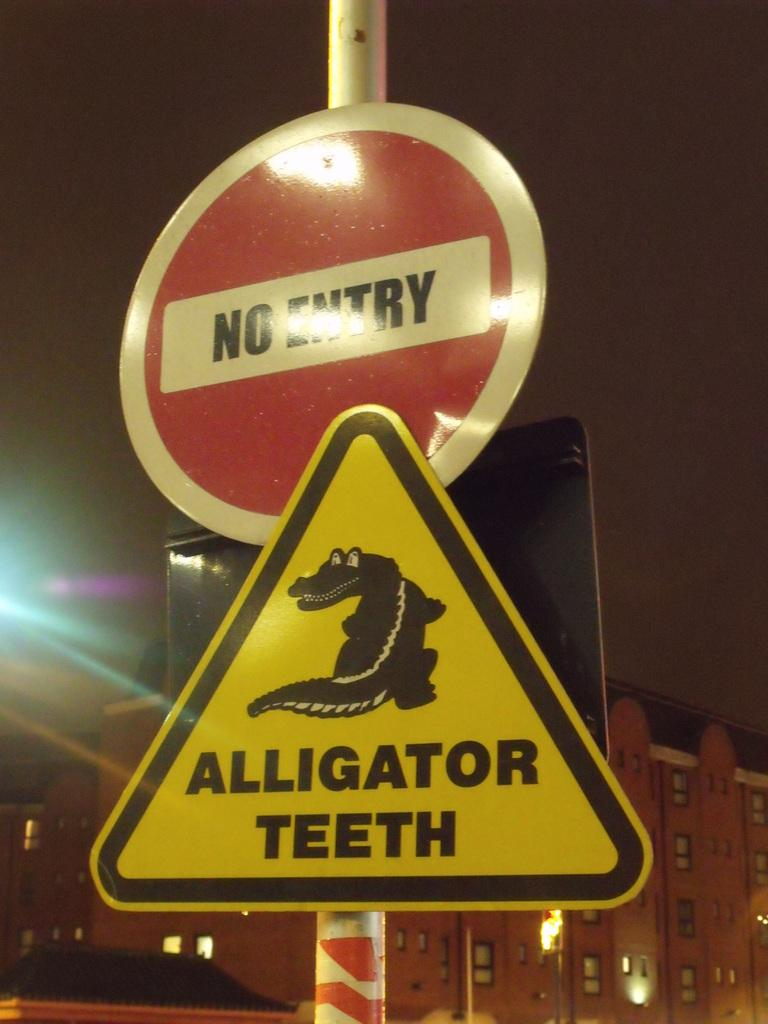<image>
Provide a brief description of the given image. two signs with one that says no entry on it 